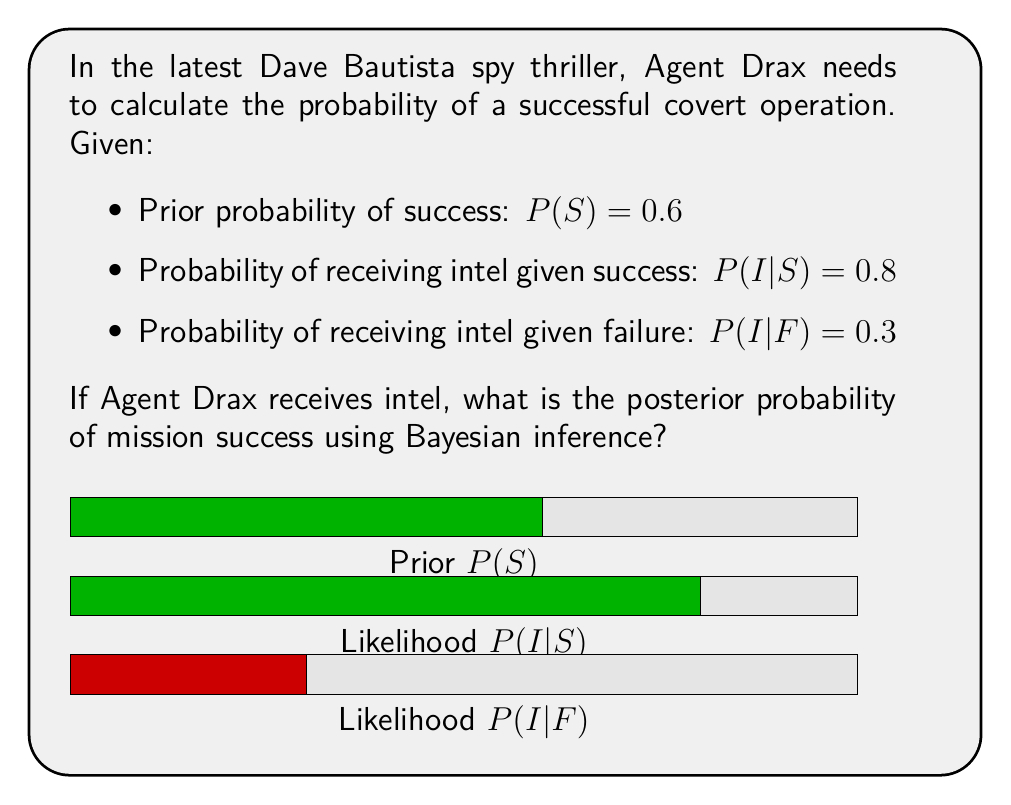Help me with this question. To solve this problem, we'll use Bayes' theorem:

$$P(S|I) = \frac{P(I|S) \cdot P(S)}{P(I)}$$

1) We're given $P(S)$, $P(I|S)$, and $P(I|F)$. We need to calculate $P(I)$.

2) Calculate $P(I)$ using the law of total probability:
   $$P(I) = P(I|S) \cdot P(S) + P(I|F) \cdot P(F)$$
   $$P(I) = 0.8 \cdot 0.6 + 0.3 \cdot (1-0.6)$$
   $$P(I) = 0.48 + 0.12 = 0.6$$

3) Now we can apply Bayes' theorem:
   $$P(S|I) = \frac{0.8 \cdot 0.6}{0.6} = 0.8$$

Therefore, the posterior probability of mission success given that intel was received is 0.8 or 80%.
Answer: $P(S|I) = 0.8$ 